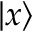<formula> <loc_0><loc_0><loc_500><loc_500>| x \rangle</formula> 